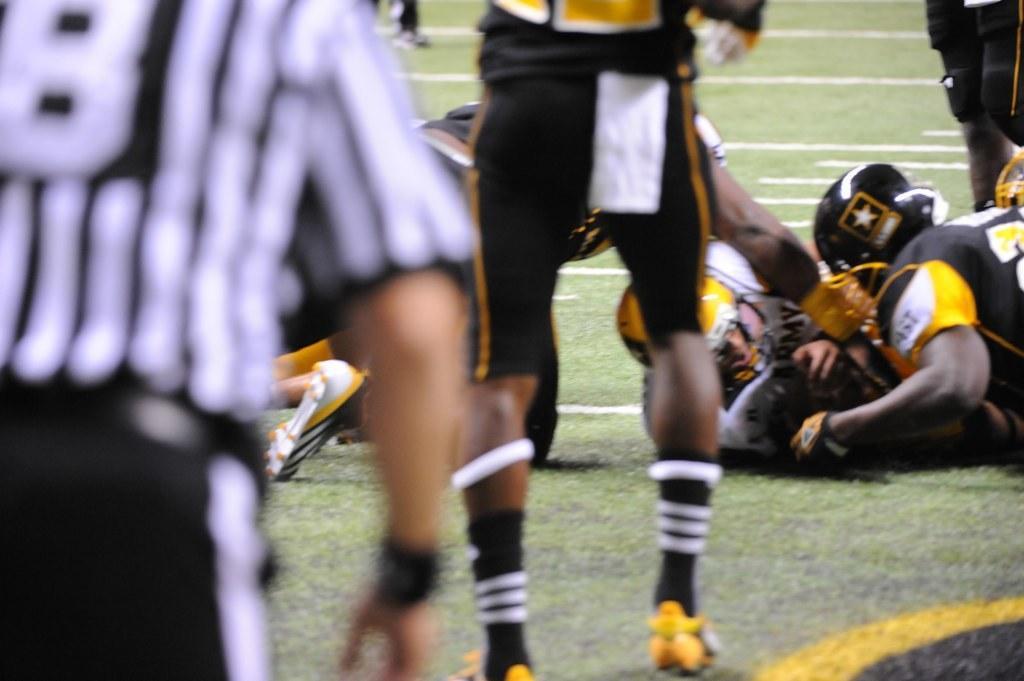Can you describe this image briefly? On the left there is an empire. In the middle of the picture we can see people playing rugby. In this picture there is a rugby ground. At the top we can see a person's legs. 